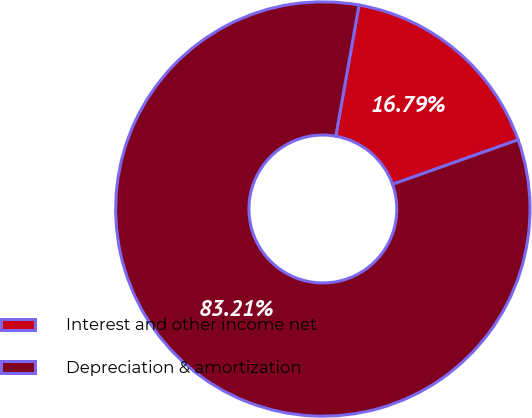Convert chart to OTSL. <chart><loc_0><loc_0><loc_500><loc_500><pie_chart><fcel>Interest and other income net<fcel>Depreciation & amortization<nl><fcel>16.79%<fcel>83.21%<nl></chart> 